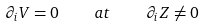Convert formula to latex. <formula><loc_0><loc_0><loc_500><loc_500>\partial _ { i } V = 0 \quad a t \quad \partial _ { i } Z \neq 0</formula> 